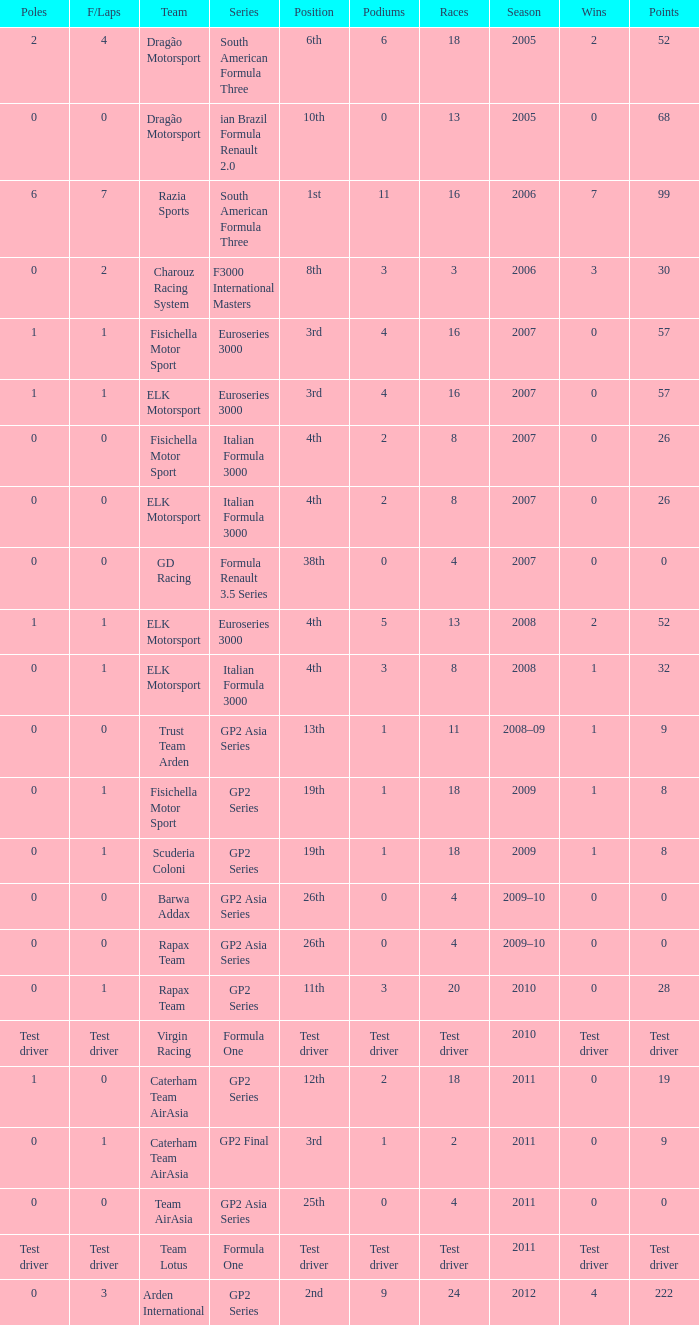In which season did he have 0 Poles and 19th position in the GP2 Series? 2009, 2009. 